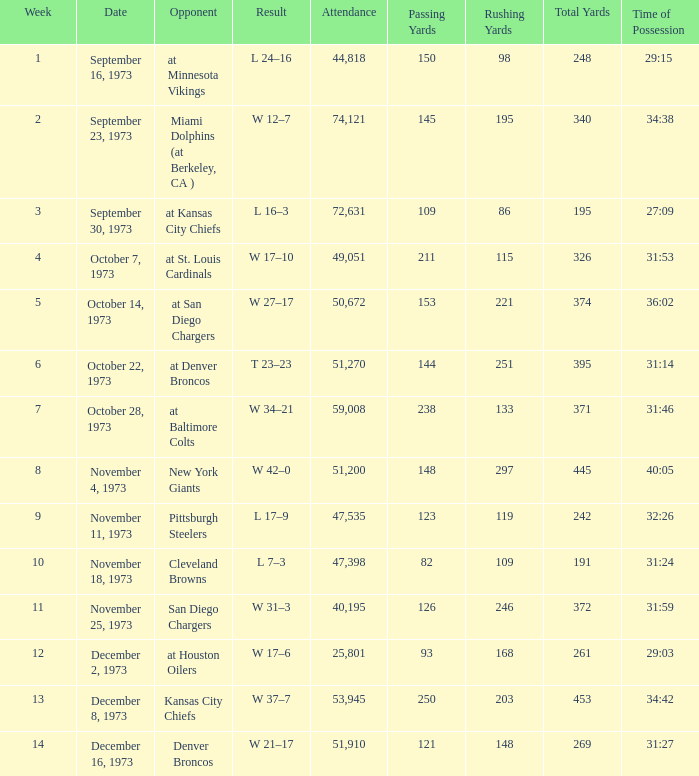What is the highest number in attendance against the game at Kansas City Chiefs? 72631.0. 